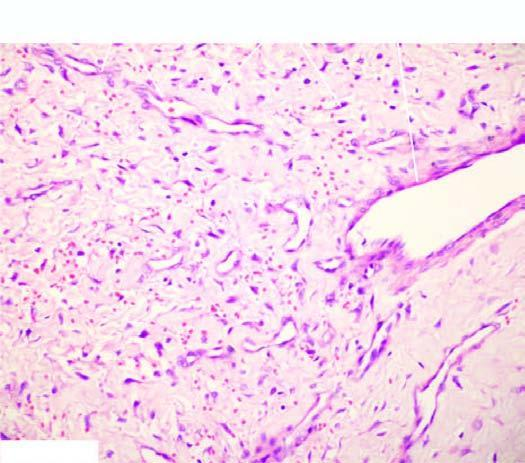s the circle shown with red line absence of elastic tissue?
Answer the question using a single word or phrase. No 